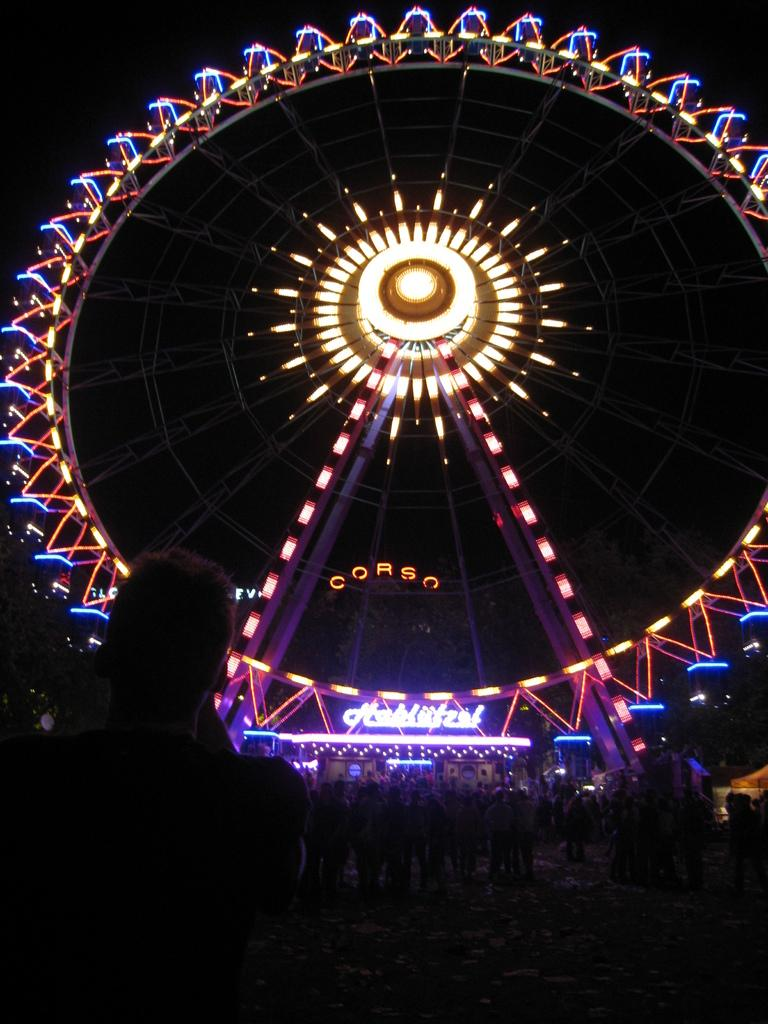What is the main feature of the image? There is a giant wheel with lights in the image. How many people are visible in front of the giant wheel? There are many people in front of the giant wheel. What type of drawer can be seen in the image? There is no drawer present in the image. How much profit can be made from the giant wheel in the image? The image does not provide information about the profitability of the giant wheel. 